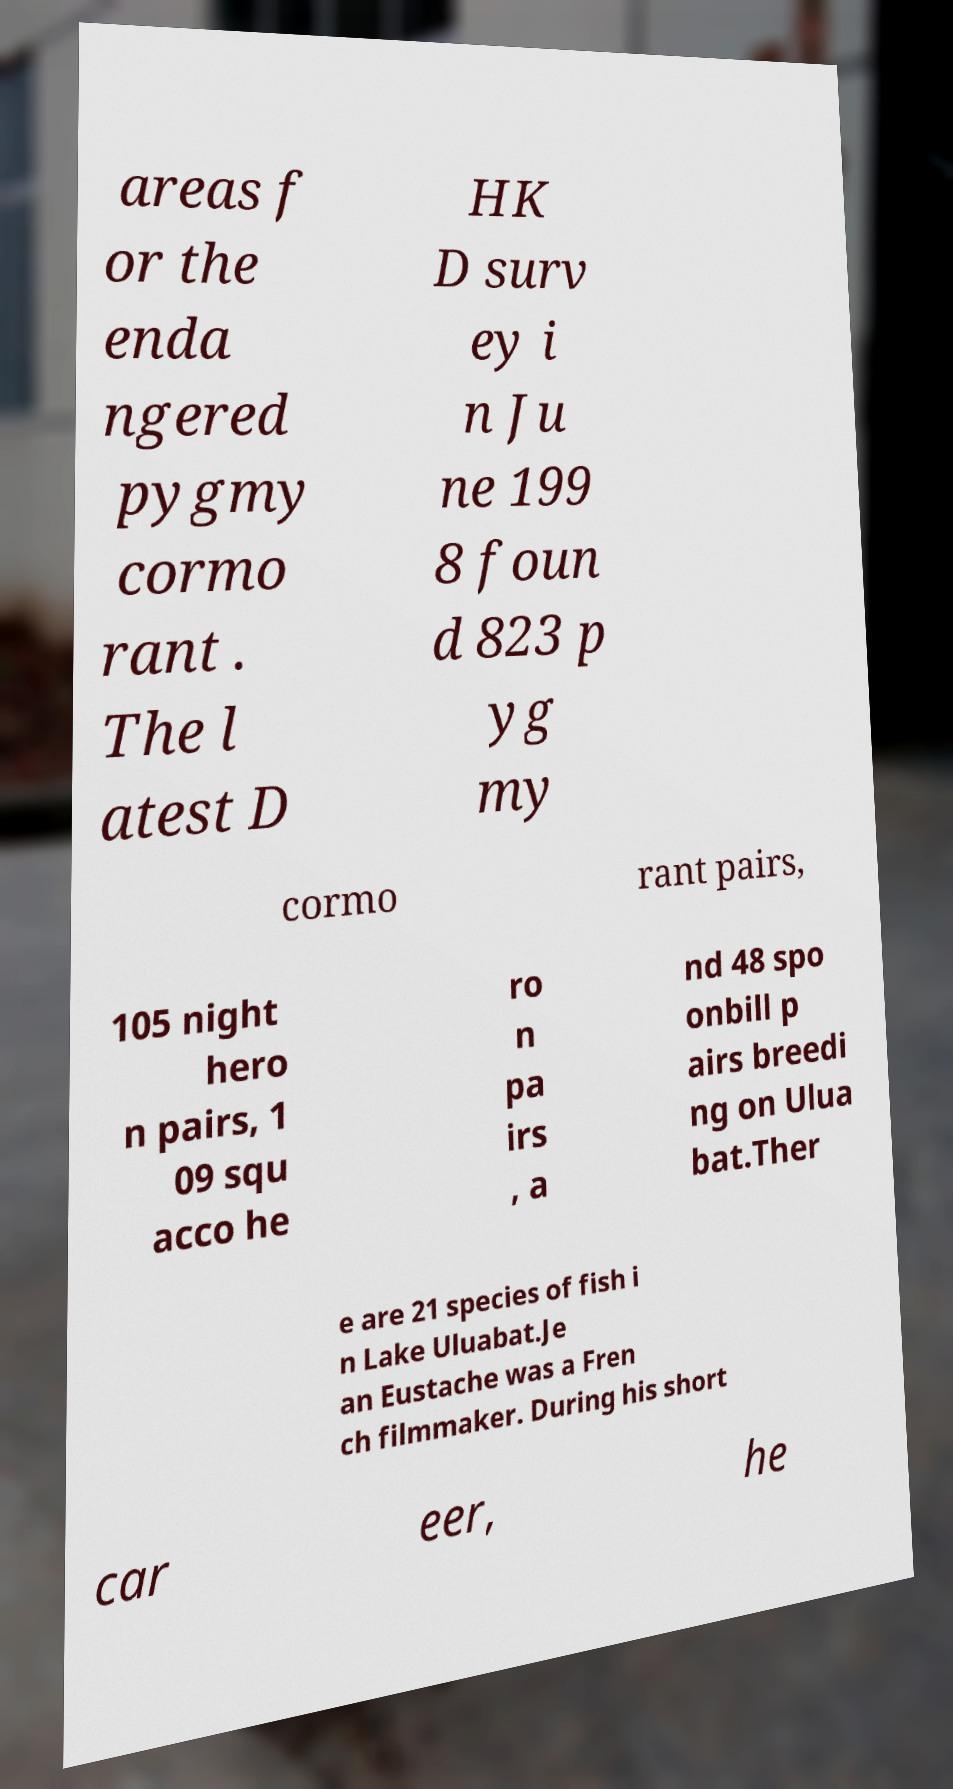For documentation purposes, I need the text within this image transcribed. Could you provide that? areas f or the enda ngered pygmy cormo rant . The l atest D HK D surv ey i n Ju ne 199 8 foun d 823 p yg my cormo rant pairs, 105 night hero n pairs, 1 09 squ acco he ro n pa irs , a nd 48 spo onbill p airs breedi ng on Ulua bat.Ther e are 21 species of fish i n Lake Uluabat.Je an Eustache was a Fren ch filmmaker. During his short car eer, he 